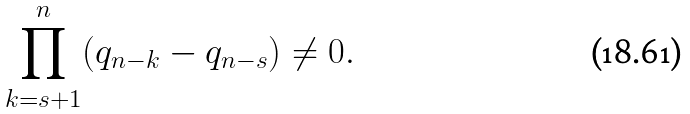<formula> <loc_0><loc_0><loc_500><loc_500>\prod _ { k = s + 1 } ^ { n } ( q _ { n - k } - q _ { n - s } ) \not = 0 .</formula> 